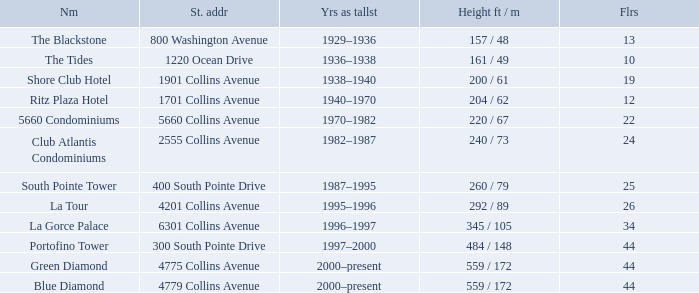What is the height of the Tides with less than 34 floors? 161 / 49. 